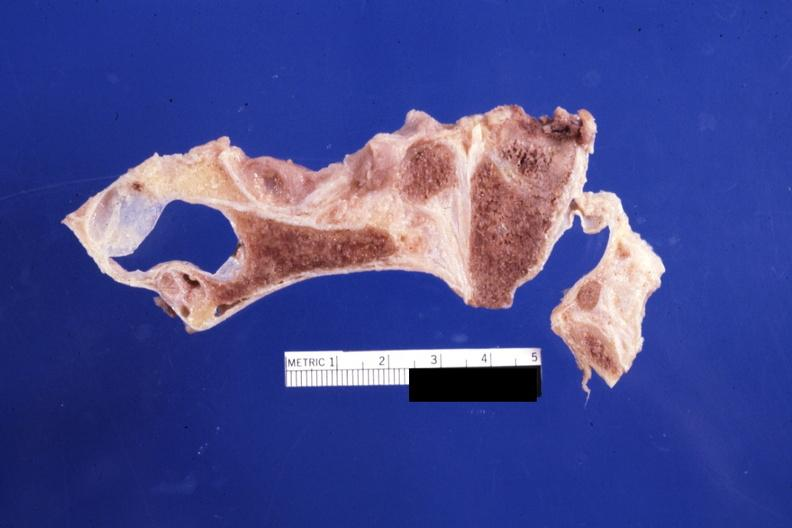s leiomyomas present?
Answer the question using a single word or phrase. No 